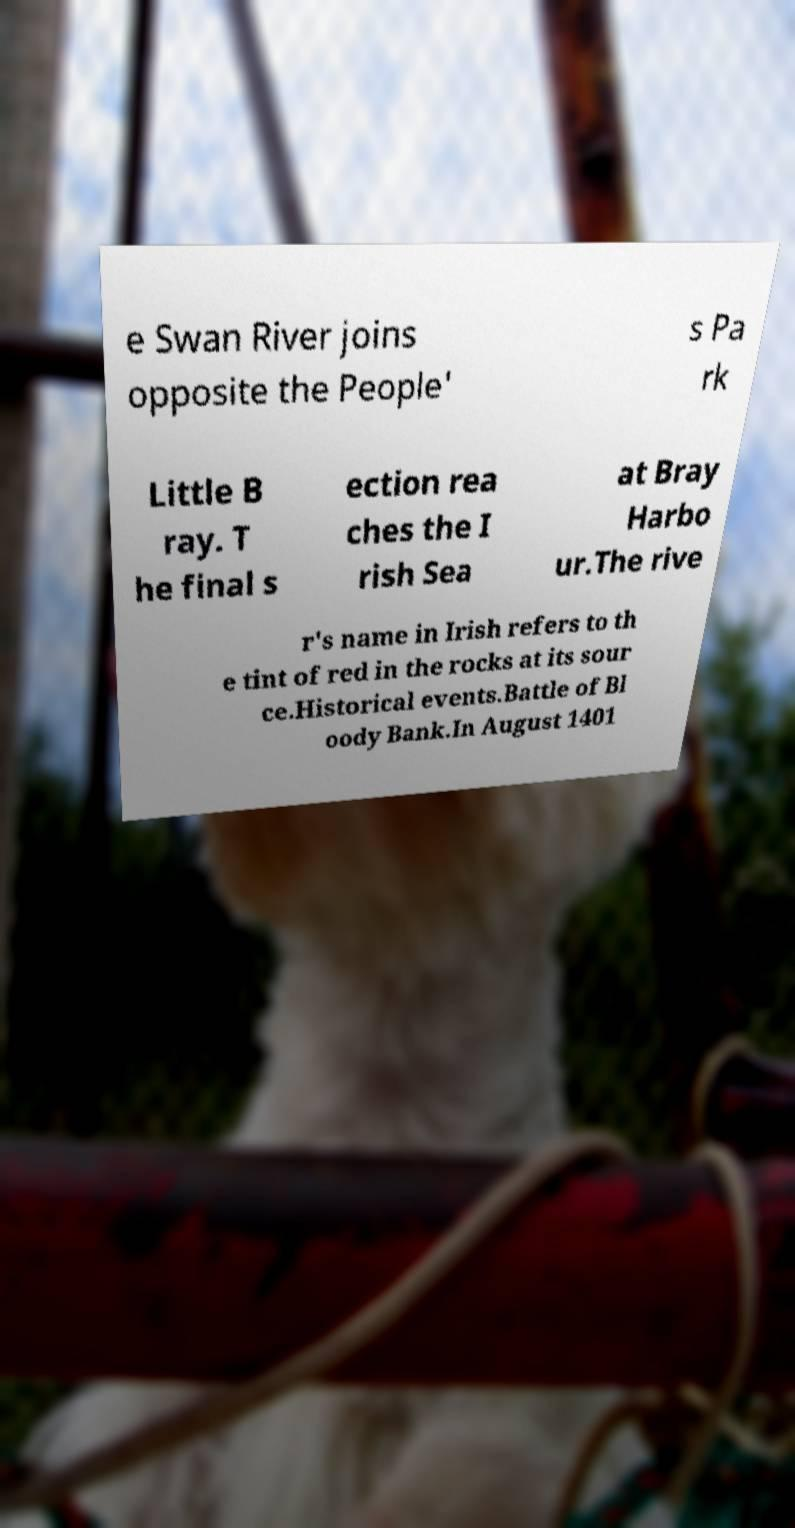For documentation purposes, I need the text within this image transcribed. Could you provide that? e Swan River joins opposite the People' s Pa rk Little B ray. T he final s ection rea ches the I rish Sea at Bray Harbo ur.The rive r's name in Irish refers to th e tint of red in the rocks at its sour ce.Historical events.Battle of Bl oody Bank.In August 1401 